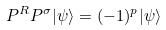<formula> <loc_0><loc_0><loc_500><loc_500>P ^ { R } P ^ { \sigma } | \psi \rangle = ( - 1 ) ^ { p } | \psi \rangle</formula> 